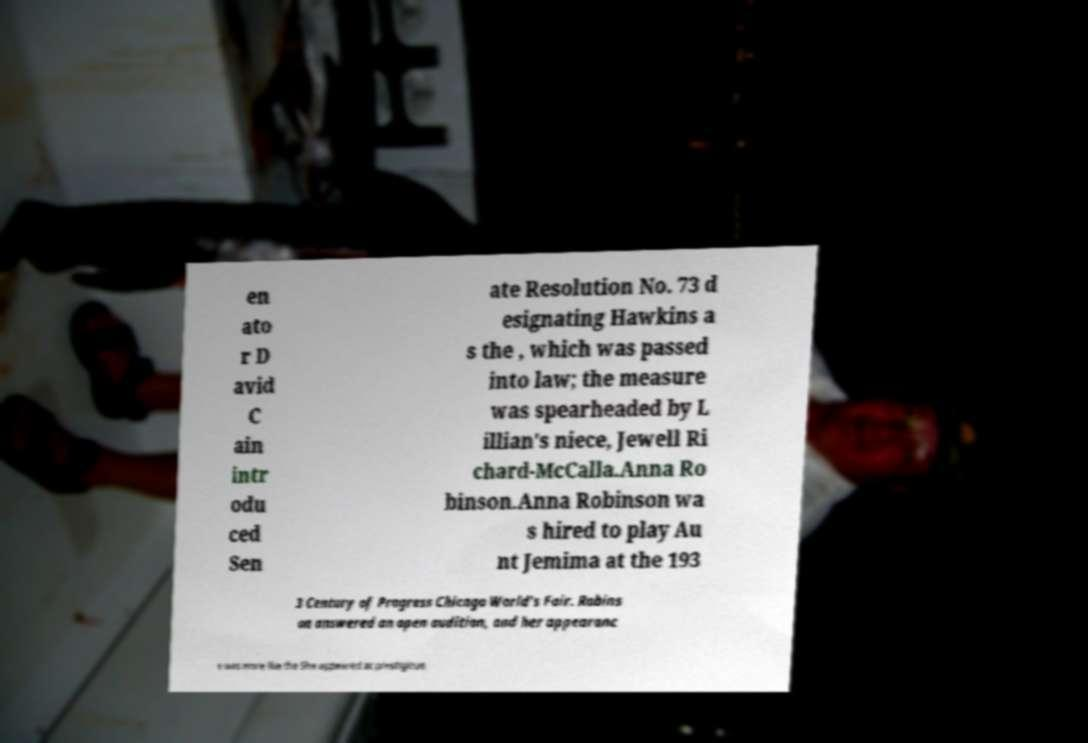For documentation purposes, I need the text within this image transcribed. Could you provide that? en ato r D avid C ain intr odu ced Sen ate Resolution No. 73 d esignating Hawkins a s the , which was passed into law; the measure was spearheaded by L illian's niece, Jewell Ri chard-McCalla.Anna Ro binson.Anna Robinson wa s hired to play Au nt Jemima at the 193 3 Century of Progress Chicago World's Fair. Robins on answered an open audition, and her appearanc e was more like the She appeared at prestigious 